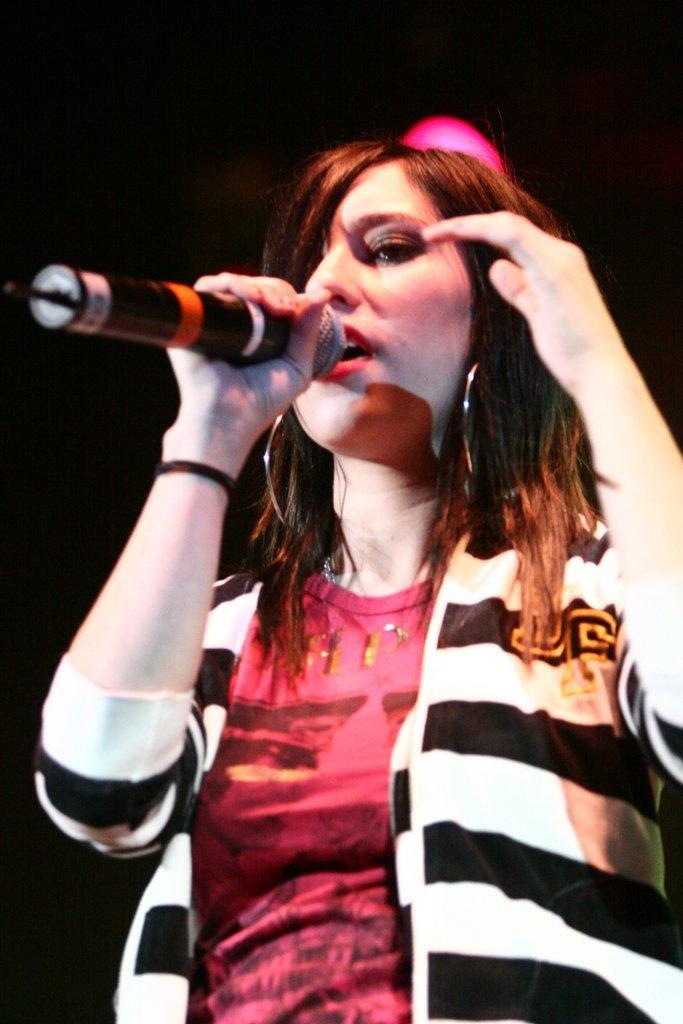What is the person in the image doing? The person is standing in the image and holding a microphone. What might the person be doing with the microphone? The person is singing while holding the microphone. What can be seen at the top of the image? There are lights visible at the top of the image. What type of food is the person cooking in the image? There is no indication in the image that the person is cooking any food. What type of bait is visible in the image? There is no bait present in the image. 